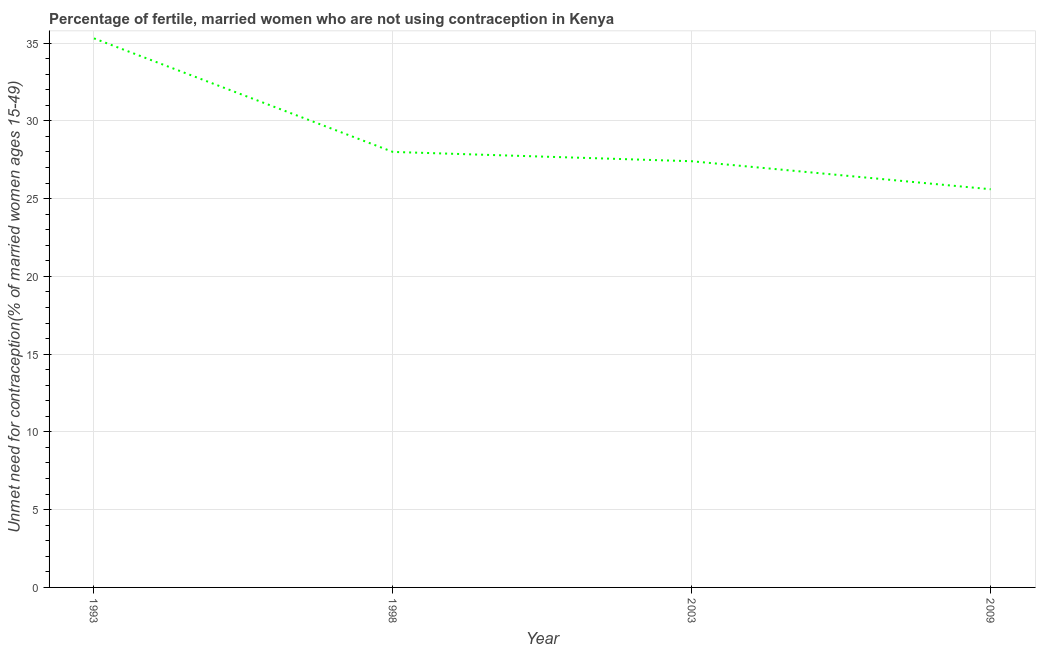What is the number of married women who are not using contraception in 2009?
Your answer should be very brief. 25.6. Across all years, what is the maximum number of married women who are not using contraception?
Your answer should be very brief. 35.3. Across all years, what is the minimum number of married women who are not using contraception?
Offer a very short reply. 25.6. What is the sum of the number of married women who are not using contraception?
Make the answer very short. 116.3. What is the difference between the number of married women who are not using contraception in 1998 and 2003?
Your response must be concise. 0.6. What is the average number of married women who are not using contraception per year?
Offer a terse response. 29.07. What is the median number of married women who are not using contraception?
Your response must be concise. 27.7. What is the ratio of the number of married women who are not using contraception in 1993 to that in 1998?
Your answer should be compact. 1.26. What is the difference between the highest and the second highest number of married women who are not using contraception?
Provide a succinct answer. 7.3. What is the difference between the highest and the lowest number of married women who are not using contraception?
Your answer should be compact. 9.7. How many lines are there?
Offer a terse response. 1. Are the values on the major ticks of Y-axis written in scientific E-notation?
Give a very brief answer. No. Does the graph contain any zero values?
Keep it short and to the point. No. What is the title of the graph?
Offer a terse response. Percentage of fertile, married women who are not using contraception in Kenya. What is the label or title of the X-axis?
Your response must be concise. Year. What is the label or title of the Y-axis?
Your response must be concise.  Unmet need for contraception(% of married women ages 15-49). What is the  Unmet need for contraception(% of married women ages 15-49) in 1993?
Give a very brief answer. 35.3. What is the  Unmet need for contraception(% of married women ages 15-49) in 2003?
Give a very brief answer. 27.4. What is the  Unmet need for contraception(% of married women ages 15-49) of 2009?
Give a very brief answer. 25.6. What is the difference between the  Unmet need for contraception(% of married women ages 15-49) in 1993 and 1998?
Keep it short and to the point. 7.3. What is the difference between the  Unmet need for contraception(% of married women ages 15-49) in 1993 and 2009?
Give a very brief answer. 9.7. What is the difference between the  Unmet need for contraception(% of married women ages 15-49) in 1998 and 2003?
Your answer should be compact. 0.6. What is the difference between the  Unmet need for contraception(% of married women ages 15-49) in 2003 and 2009?
Your response must be concise. 1.8. What is the ratio of the  Unmet need for contraception(% of married women ages 15-49) in 1993 to that in 1998?
Make the answer very short. 1.26. What is the ratio of the  Unmet need for contraception(% of married women ages 15-49) in 1993 to that in 2003?
Offer a very short reply. 1.29. What is the ratio of the  Unmet need for contraception(% of married women ages 15-49) in 1993 to that in 2009?
Make the answer very short. 1.38. What is the ratio of the  Unmet need for contraception(% of married women ages 15-49) in 1998 to that in 2003?
Offer a very short reply. 1.02. What is the ratio of the  Unmet need for contraception(% of married women ages 15-49) in 1998 to that in 2009?
Make the answer very short. 1.09. What is the ratio of the  Unmet need for contraception(% of married women ages 15-49) in 2003 to that in 2009?
Your answer should be compact. 1.07. 